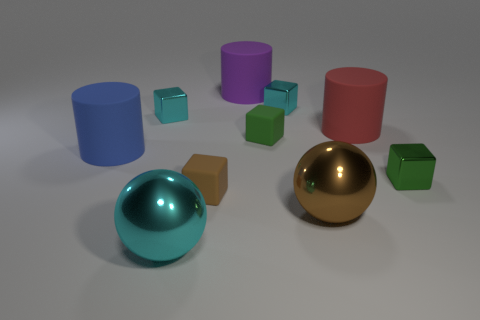Subtract 1 cubes. How many cubes are left? 4 Subtract all brown cubes. How many cubes are left? 4 Subtract all brown cubes. How many cubes are left? 4 Subtract all purple blocks. Subtract all brown cylinders. How many blocks are left? 5 Subtract all spheres. How many objects are left? 8 Subtract 0 yellow cylinders. How many objects are left? 10 Subtract all purple cylinders. Subtract all cylinders. How many objects are left? 6 Add 9 big cyan metal spheres. How many big cyan metal spheres are left? 10 Add 7 green blocks. How many green blocks exist? 9 